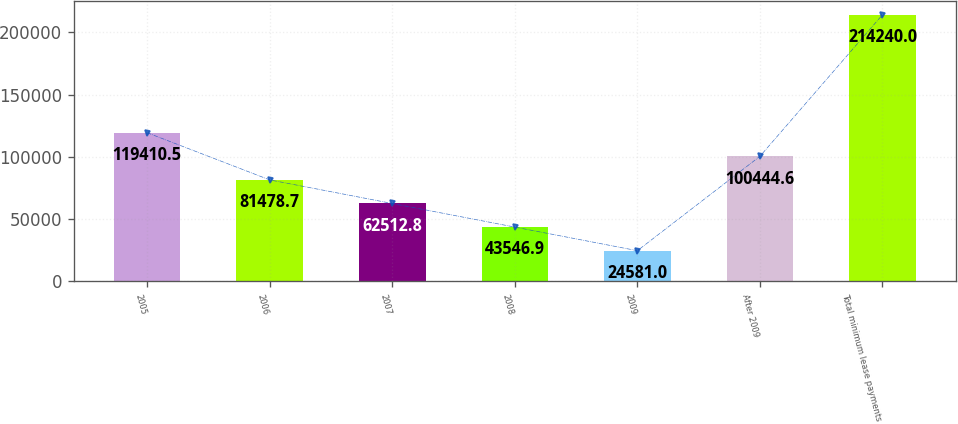<chart> <loc_0><loc_0><loc_500><loc_500><bar_chart><fcel>2005<fcel>2006<fcel>2007<fcel>2008<fcel>2009<fcel>After 2009<fcel>Total minimum lease payments<nl><fcel>119410<fcel>81478.7<fcel>62512.8<fcel>43546.9<fcel>24581<fcel>100445<fcel>214240<nl></chart> 